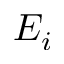Convert formula to latex. <formula><loc_0><loc_0><loc_500><loc_500>E _ { i }</formula> 